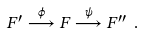<formula> <loc_0><loc_0><loc_500><loc_500>F ^ { \prime } \overset { \phi } { \longrightarrow } F \overset { \psi } { \longrightarrow } F ^ { \prime \prime } \ .</formula> 